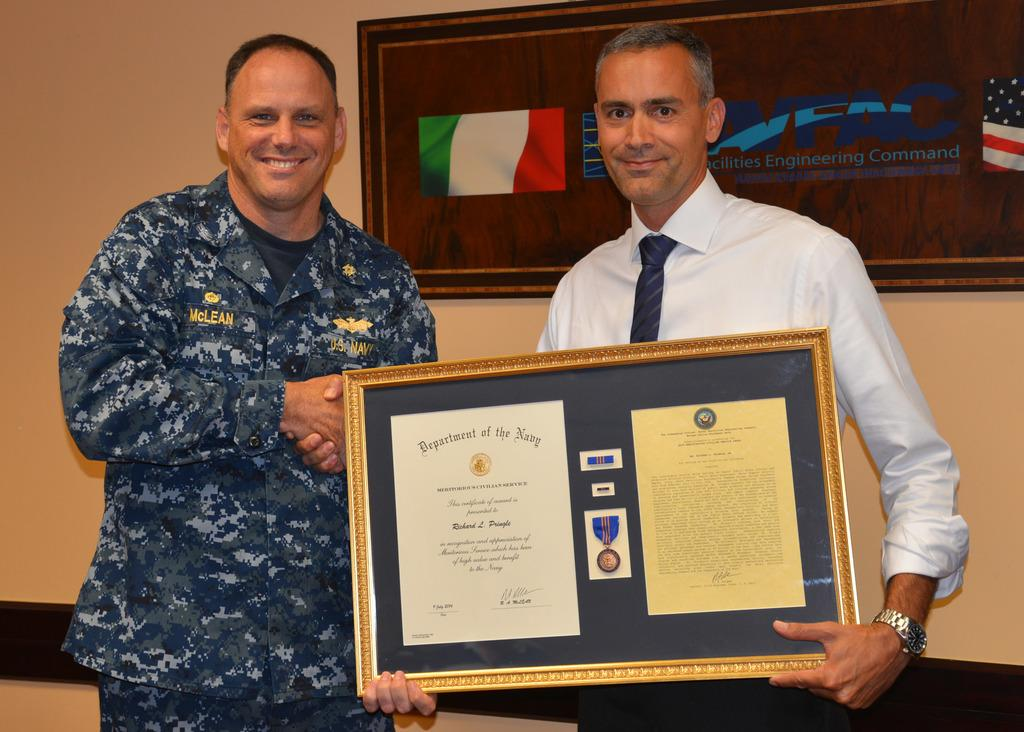How many people are in the image? There are two men in the image. What is the facial expression of the men in the image? Both men are smiling. What is one of the men holding in the image? One man is holding a frame with his hands. What can be seen on the wall in the background of the image? There is a board on the wall in the background of the image. What type of lamp is hanging above the men in the image? There is no lamp present in the image. What agreement were the men discussing before the image was taken? The image does not provide any information about an agreement or discussion between the men. 